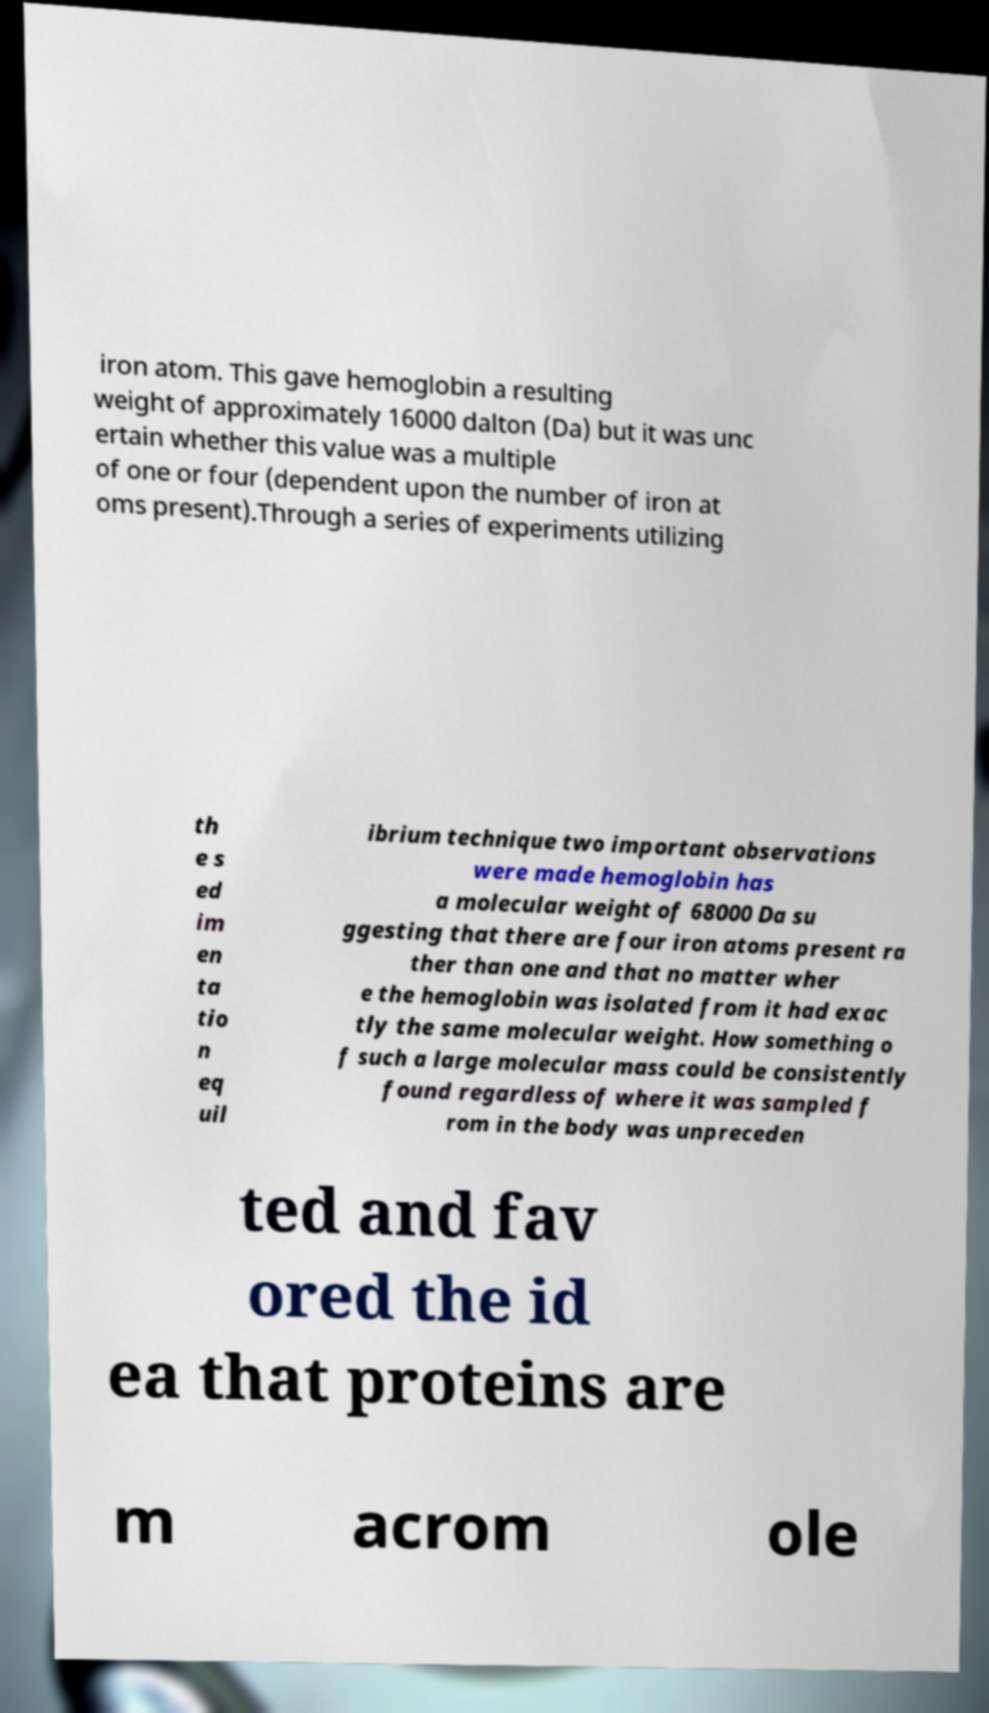There's text embedded in this image that I need extracted. Can you transcribe it verbatim? iron atom. This gave hemoglobin a resulting weight of approximately 16000 dalton (Da) but it was unc ertain whether this value was a multiple of one or four (dependent upon the number of iron at oms present).Through a series of experiments utilizing th e s ed im en ta tio n eq uil ibrium technique two important observations were made hemoglobin has a molecular weight of 68000 Da su ggesting that there are four iron atoms present ra ther than one and that no matter wher e the hemoglobin was isolated from it had exac tly the same molecular weight. How something o f such a large molecular mass could be consistently found regardless of where it was sampled f rom in the body was unpreceden ted and fav ored the id ea that proteins are m acrom ole 